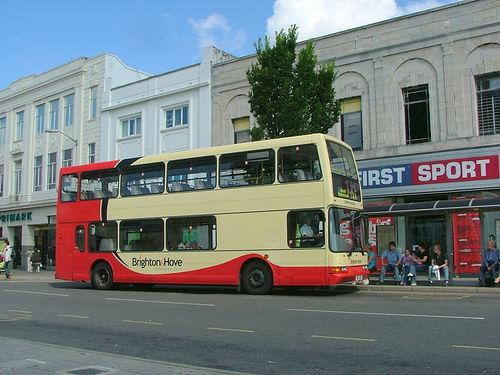Question: who is driving the bus?
Choices:
A. A pilot.
B. A taxi driver.
C. A tour guide.
D. A bus driver.
Answer with the letter. Answer: D Question: when was this picture taken?
Choices:
A. During the day.
B. At night.
C. At dawn.
D. At twilight.
Answer with the letter. Answer: A Question: what does the sign in red say on the right side of the picture?
Choices:
A. Stop.
B. Walk.
C. Parking.
D. SPORT.
Answer with the letter. Answer: D Question: how many people are sitting down waiting for the bus?
Choices:
A. 5.
B. 6.
C. 4.
D. 3.
Answer with the letter. Answer: B Question: how many people do you see on the top part of the bus?
Choices:
A. 1.
B. 2.
C. 3.
D. 0.
Answer with the letter. Answer: D 